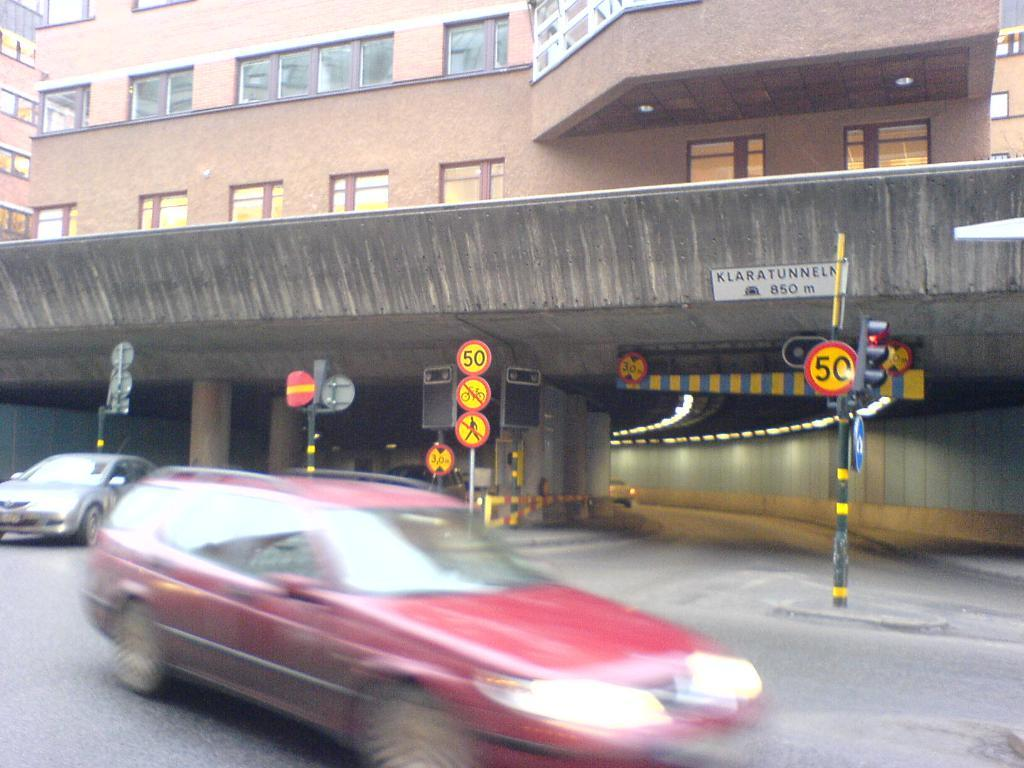<image>
Relay a brief, clear account of the picture shown. A red station wagon is driving by the entrance to an underpass with the sign that reads klaratunneln over the entrance. 